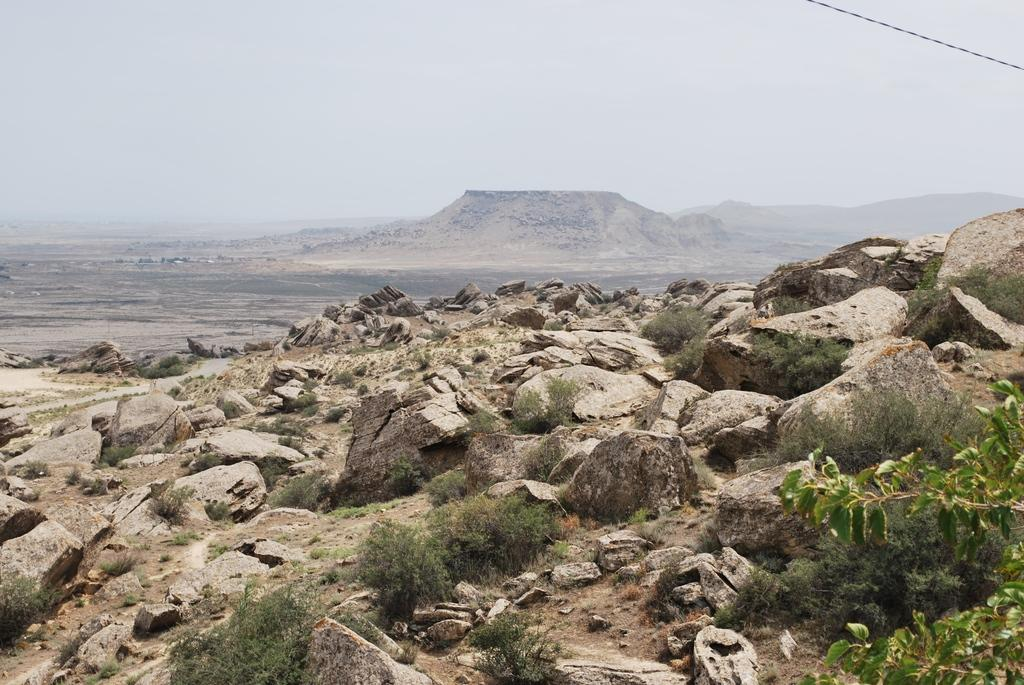What is the main feature of the surface in the image? There are rocks on the surface in the image. What else can be seen on the surface with rocks? There are plants on the surface with rocks. What can be seen in the background of the image? There is another surface with rocks and hills in the background. What is visible above the surface and hills in the image? The sky is visible in the background. How many sisters are playing with their daughter on the rocks in the image? There are no people, including sisters or daughters, present in the image. 